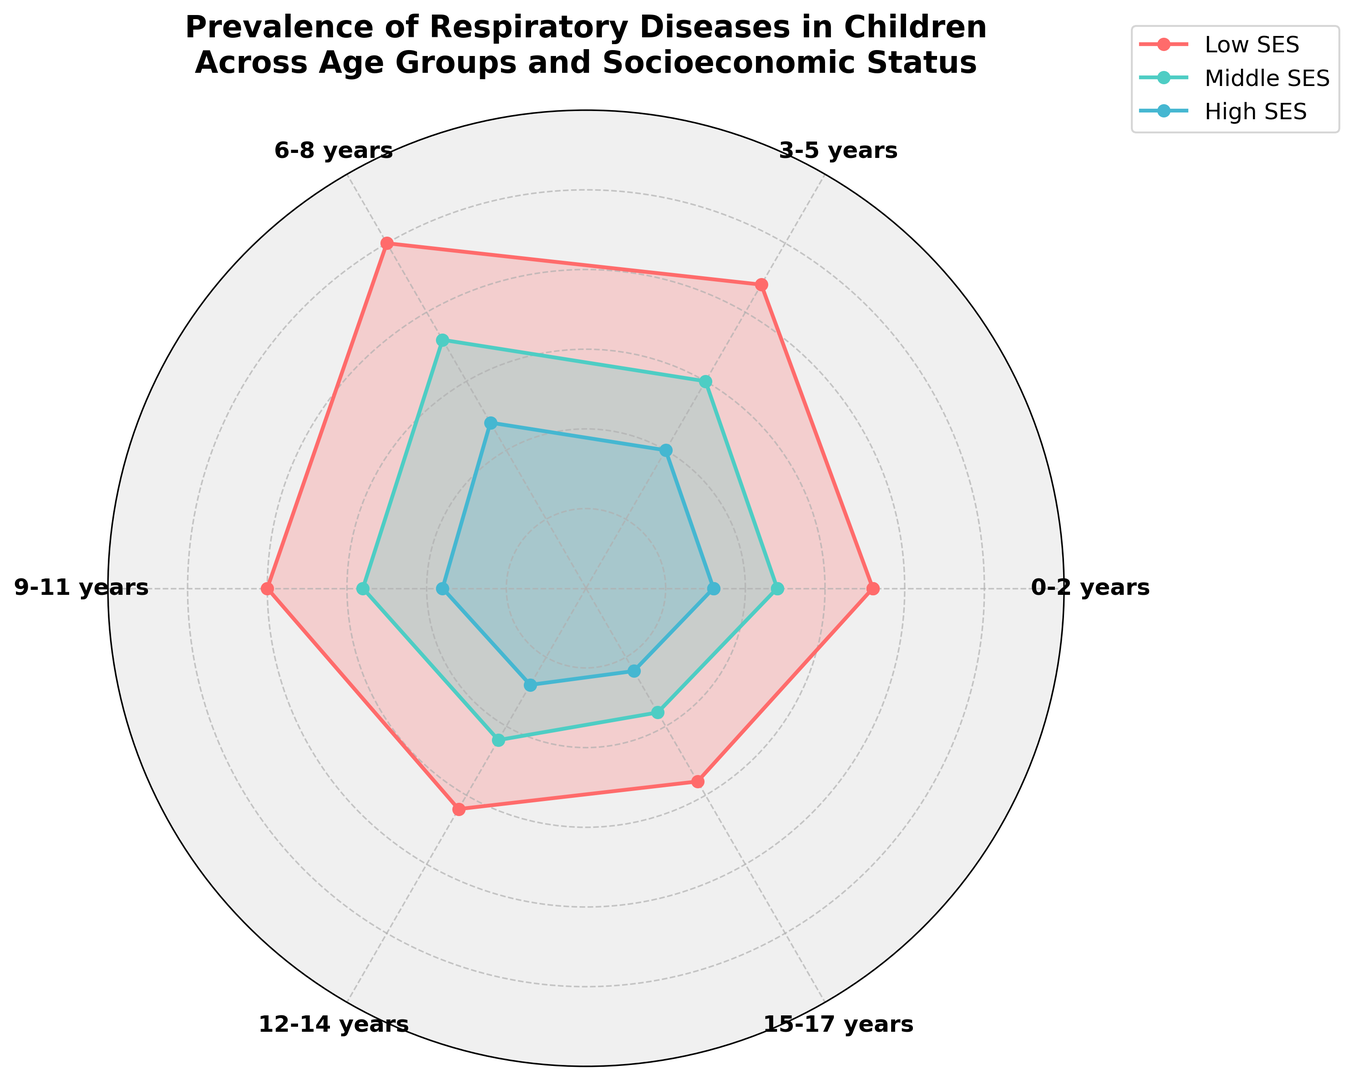What age group has the highest prevalence of respiratory diseases in children among the Low SES group? To find the age group with the highest prevalence of respiratory diseases in the Low SES group, look at the red line. The highest point on the red line corresponds to the angle labeled "6-8 years" because that point has the highest value.
Answer: 6-8 years By how many percentage points is the prevalence of respiratory diseases in children aged 3-5 years from Low SES higher than that from High SES? Locate both points corresponding to the 3-5 years age group. The red line (Low SES) is at 22 percentage points, and the blue line (High SES) is at 10 percentage points. Subtract the High SES value from the Low SES value (22 - 10).
Answer: 12 percentage points Visualizing the trend of respiratory diseases in children from Low SES across age groups, what general pattern can you describe? Observe the red line's overall shape. It rises from 0-2 years to 6-8 years, then declines steadily from 6-8 years to 15-17 years. This indicates an increase in prevalence up to 6-8 years, followed by a decrease for older age groups.
Answer: Increases until 6-8 years, then decreases Which socioeconomic status group shows the least variation in the prevalence of respiratory diseases across all age groups? Compare the spread of the red, green, and blue lines. The blue line (High SES) has relatively flat and closely grouped values, suggesting the least variation.
Answer: High SES By how many percentage points does the prevalence of respiratory diseases in children from Middle SES aged 9-11 years differ from the average prevalence of respiratory diseases in children from High SES across all age groups? First, find the prevalence in Middle SES for 9-11 years (14 percentage points). To find the average prevalence in High SES, sum the values (8+10+12+9+7+6) to get 52 and divide by 6 (52/6 approximately 8.67). Subtract the average prevalence from High SES from the 9-11 years in Middle SES (14 - 8.67).
Answer: Approximately 5.33 percentage points Of the three socioeconomic groups, which age group consistently shows the lowest prevalence of respiratory disease? Examine the red, green, and blue lines across all age groups. The data indicates that children aged 15-17 years in all groups have relatively low points across the chart.
Answer: 15-17 years What is the total prevalence of respiratory diseases in children from Low SES across all age groups combined? Sum the values from the Low SES line (18 + 22 + 25 + 20 + 16 + 14). Summing these gives 115 percentage points.
Answer: 115 percentage points 